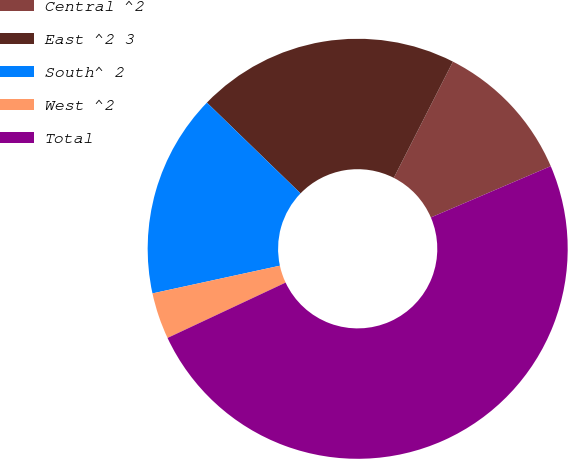Convert chart to OTSL. <chart><loc_0><loc_0><loc_500><loc_500><pie_chart><fcel>Central ^2<fcel>East ^2 3<fcel>South^ 2<fcel>West ^2<fcel>Total<nl><fcel>11.07%<fcel>20.24%<fcel>15.66%<fcel>3.57%<fcel>49.46%<nl></chart> 